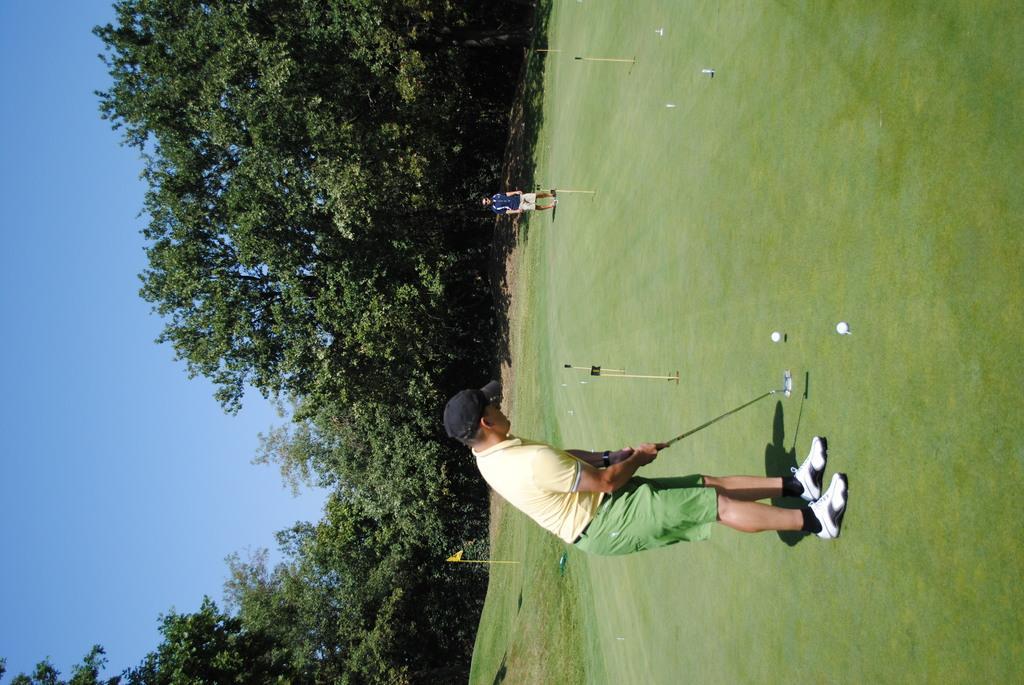Describe this image in one or two sentences. In this picture I can see there are some people standing and playing hockey. In the backdrop there are some trees and the sky is clear. 